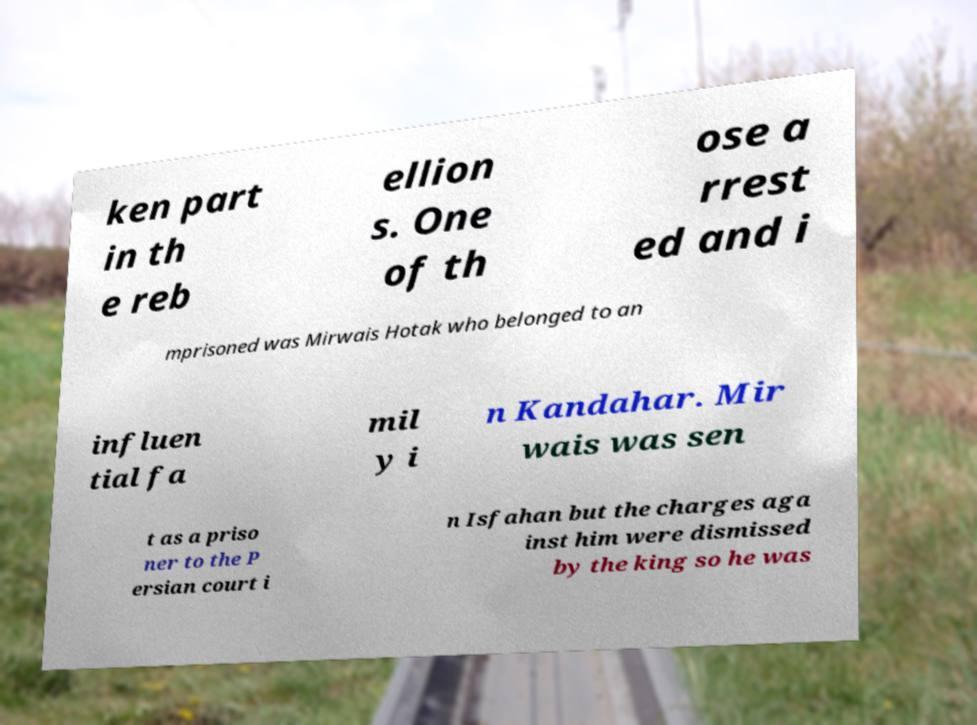Please identify and transcribe the text found in this image. ken part in th e reb ellion s. One of th ose a rrest ed and i mprisoned was Mirwais Hotak who belonged to an influen tial fa mil y i n Kandahar. Mir wais was sen t as a priso ner to the P ersian court i n Isfahan but the charges aga inst him were dismissed by the king so he was 